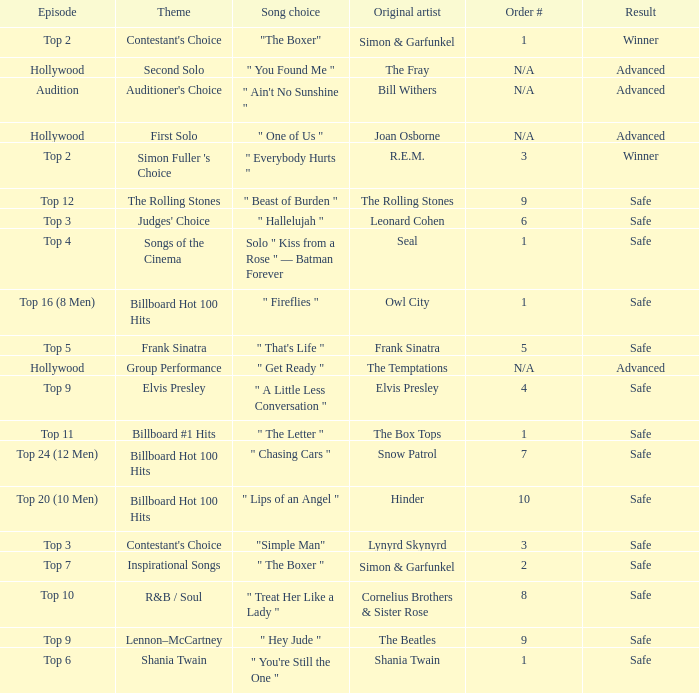In which installment is the 10th order number featured? Top 20 (10 Men). 